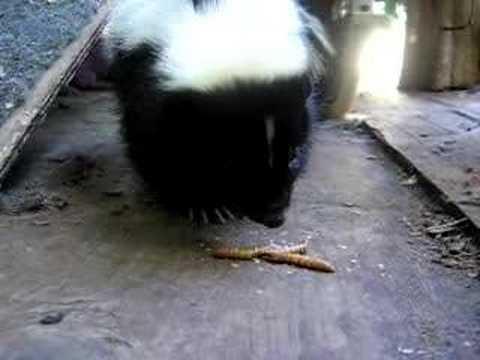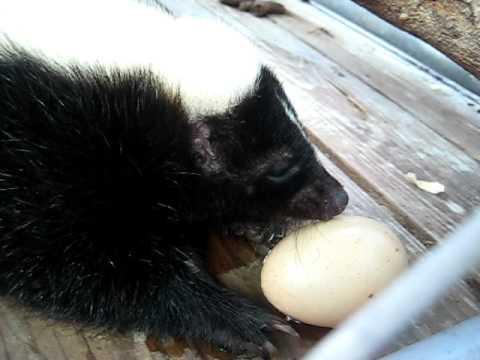The first image is the image on the left, the second image is the image on the right. Given the left and right images, does the statement "The right image shows one rightward-facing skunk with an oval food item in front of its nose." hold true? Answer yes or no. Yes. The first image is the image on the left, the second image is the image on the right. For the images displayed, is the sentence "There are only two skunks." factually correct? Answer yes or no. Yes. 